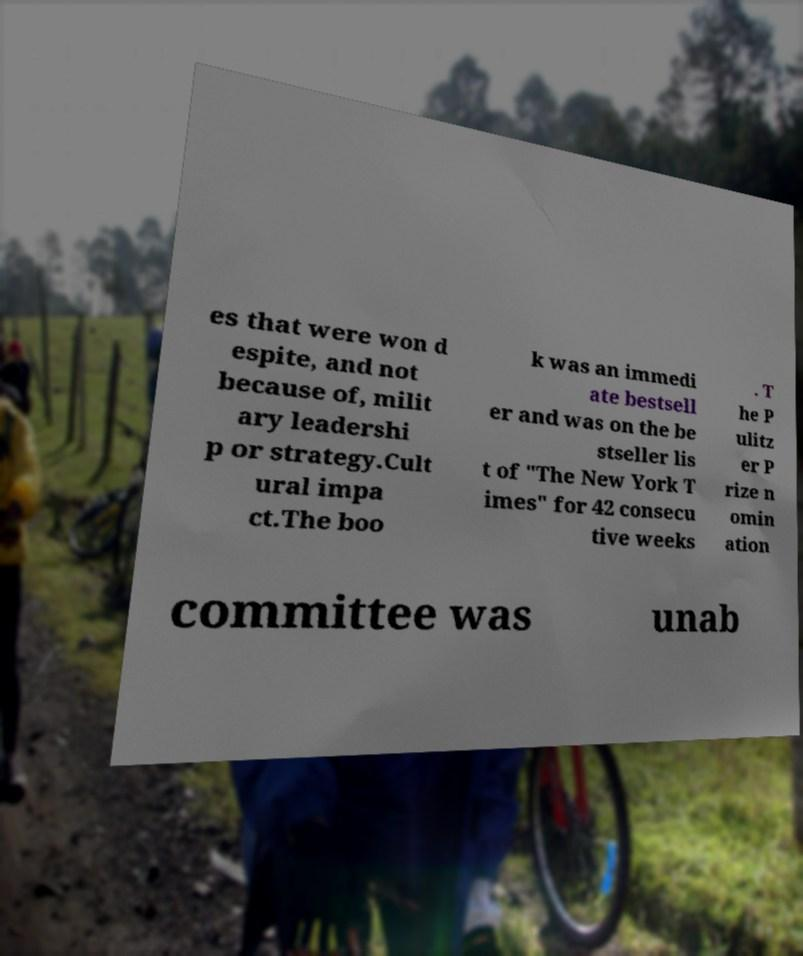What messages or text are displayed in this image? I need them in a readable, typed format. es that were won d espite, and not because of, milit ary leadershi p or strategy.Cult ural impa ct.The boo k was an immedi ate bestsell er and was on the be stseller lis t of "The New York T imes" for 42 consecu tive weeks . T he P ulitz er P rize n omin ation committee was unab 